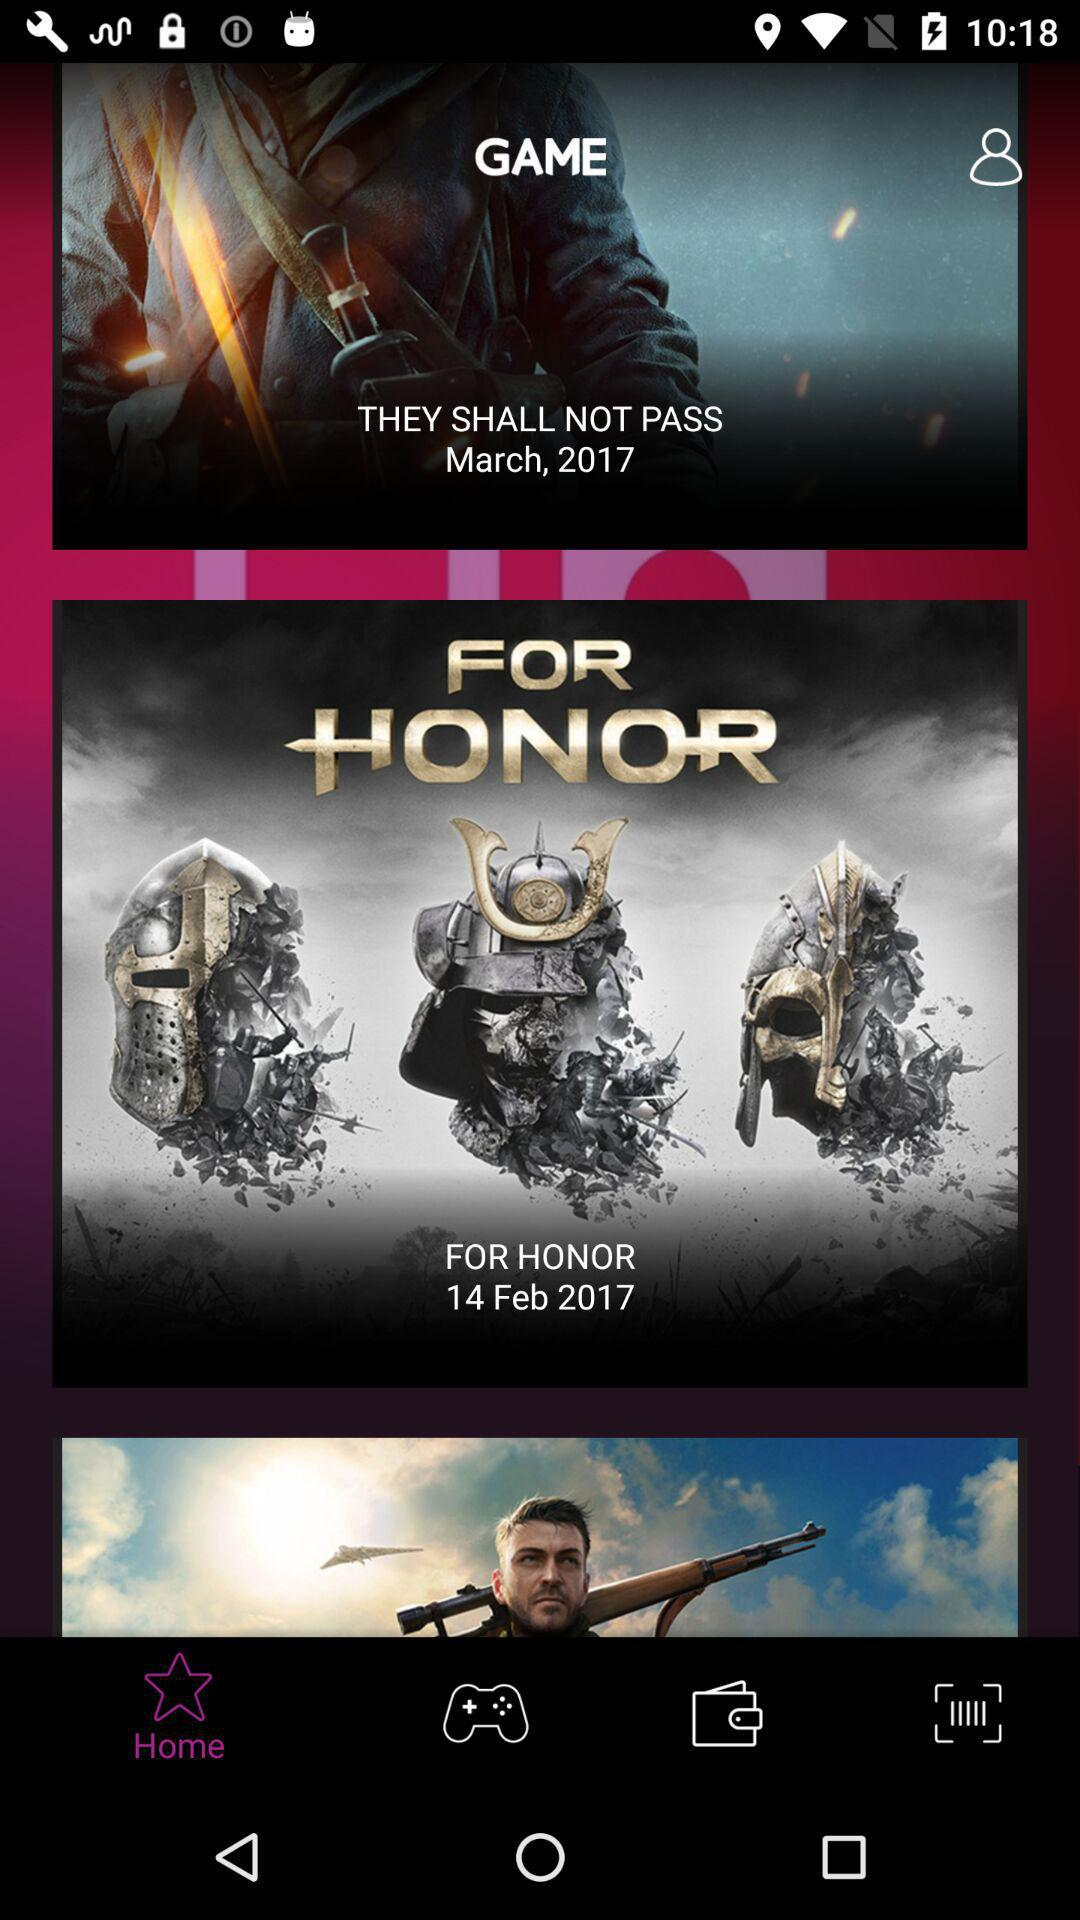Which tab is selected? The selected tab is "Home". 